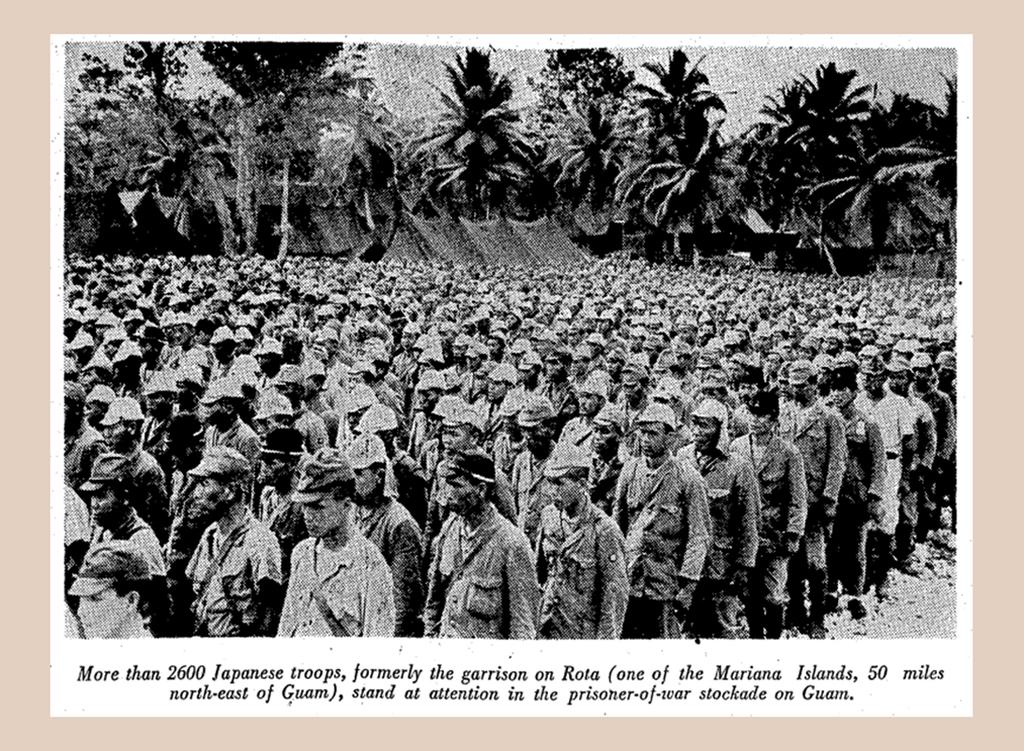What kind of troops are these?
Provide a short and direct response. Japanese. How many troops are listed?
Provide a succinct answer. 2600. 